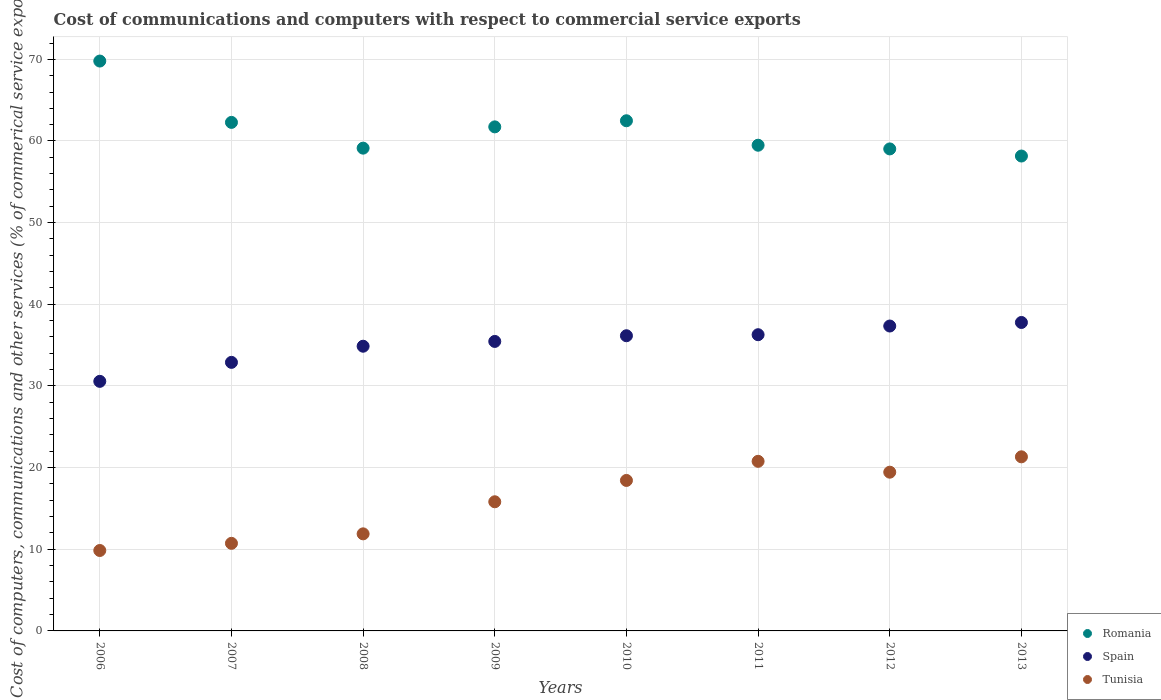Is the number of dotlines equal to the number of legend labels?
Provide a succinct answer. Yes. What is the cost of communications and computers in Romania in 2012?
Your response must be concise. 59.03. Across all years, what is the maximum cost of communications and computers in Romania?
Your response must be concise. 69.79. Across all years, what is the minimum cost of communications and computers in Tunisia?
Your response must be concise. 9.85. In which year was the cost of communications and computers in Spain maximum?
Offer a very short reply. 2013. What is the total cost of communications and computers in Romania in the graph?
Your answer should be very brief. 492.07. What is the difference between the cost of communications and computers in Spain in 2009 and that in 2011?
Provide a succinct answer. -0.82. What is the difference between the cost of communications and computers in Tunisia in 2009 and the cost of communications and computers in Romania in 2007?
Provide a succinct answer. -46.46. What is the average cost of communications and computers in Romania per year?
Make the answer very short. 61.51. In the year 2010, what is the difference between the cost of communications and computers in Spain and cost of communications and computers in Tunisia?
Your response must be concise. 17.72. What is the ratio of the cost of communications and computers in Romania in 2007 to that in 2010?
Ensure brevity in your answer.  1. Is the difference between the cost of communications and computers in Spain in 2007 and 2008 greater than the difference between the cost of communications and computers in Tunisia in 2007 and 2008?
Your answer should be very brief. No. What is the difference between the highest and the second highest cost of communications and computers in Tunisia?
Ensure brevity in your answer.  0.55. What is the difference between the highest and the lowest cost of communications and computers in Spain?
Keep it short and to the point. 7.21. Is it the case that in every year, the sum of the cost of communications and computers in Romania and cost of communications and computers in Spain  is greater than the cost of communications and computers in Tunisia?
Make the answer very short. Yes. How many years are there in the graph?
Ensure brevity in your answer.  8. Are the values on the major ticks of Y-axis written in scientific E-notation?
Give a very brief answer. No. Does the graph contain any zero values?
Your response must be concise. No. Does the graph contain grids?
Offer a terse response. Yes. How are the legend labels stacked?
Make the answer very short. Vertical. What is the title of the graph?
Your answer should be compact. Cost of communications and computers with respect to commercial service exports. What is the label or title of the X-axis?
Provide a succinct answer. Years. What is the label or title of the Y-axis?
Your answer should be very brief. Cost of computers, communications and other services (% of commerical service exports). What is the Cost of computers, communications and other services (% of commerical service exports) in Romania in 2006?
Make the answer very short. 69.79. What is the Cost of computers, communications and other services (% of commerical service exports) in Spain in 2006?
Offer a very short reply. 30.56. What is the Cost of computers, communications and other services (% of commerical service exports) in Tunisia in 2006?
Give a very brief answer. 9.85. What is the Cost of computers, communications and other services (% of commerical service exports) in Romania in 2007?
Your answer should be compact. 62.28. What is the Cost of computers, communications and other services (% of commerical service exports) of Spain in 2007?
Give a very brief answer. 32.89. What is the Cost of computers, communications and other services (% of commerical service exports) in Tunisia in 2007?
Your answer should be very brief. 10.73. What is the Cost of computers, communications and other services (% of commerical service exports) of Romania in 2008?
Keep it short and to the point. 59.12. What is the Cost of computers, communications and other services (% of commerical service exports) of Spain in 2008?
Provide a short and direct response. 34.87. What is the Cost of computers, communications and other services (% of commerical service exports) of Tunisia in 2008?
Keep it short and to the point. 11.89. What is the Cost of computers, communications and other services (% of commerical service exports) in Romania in 2009?
Your response must be concise. 61.73. What is the Cost of computers, communications and other services (% of commerical service exports) of Spain in 2009?
Make the answer very short. 35.45. What is the Cost of computers, communications and other services (% of commerical service exports) in Tunisia in 2009?
Make the answer very short. 15.82. What is the Cost of computers, communications and other services (% of commerical service exports) of Romania in 2010?
Give a very brief answer. 62.48. What is the Cost of computers, communications and other services (% of commerical service exports) in Spain in 2010?
Offer a terse response. 36.15. What is the Cost of computers, communications and other services (% of commerical service exports) of Tunisia in 2010?
Ensure brevity in your answer.  18.43. What is the Cost of computers, communications and other services (% of commerical service exports) in Romania in 2011?
Provide a succinct answer. 59.48. What is the Cost of computers, communications and other services (% of commerical service exports) in Spain in 2011?
Ensure brevity in your answer.  36.28. What is the Cost of computers, communications and other services (% of commerical service exports) in Tunisia in 2011?
Give a very brief answer. 20.77. What is the Cost of computers, communications and other services (% of commerical service exports) in Romania in 2012?
Keep it short and to the point. 59.03. What is the Cost of computers, communications and other services (% of commerical service exports) of Spain in 2012?
Offer a very short reply. 37.34. What is the Cost of computers, communications and other services (% of commerical service exports) in Tunisia in 2012?
Offer a very short reply. 19.44. What is the Cost of computers, communications and other services (% of commerical service exports) of Romania in 2013?
Your answer should be very brief. 58.16. What is the Cost of computers, communications and other services (% of commerical service exports) in Spain in 2013?
Ensure brevity in your answer.  37.77. What is the Cost of computers, communications and other services (% of commerical service exports) in Tunisia in 2013?
Give a very brief answer. 21.32. Across all years, what is the maximum Cost of computers, communications and other services (% of commerical service exports) of Romania?
Your answer should be very brief. 69.79. Across all years, what is the maximum Cost of computers, communications and other services (% of commerical service exports) in Spain?
Keep it short and to the point. 37.77. Across all years, what is the maximum Cost of computers, communications and other services (% of commerical service exports) in Tunisia?
Keep it short and to the point. 21.32. Across all years, what is the minimum Cost of computers, communications and other services (% of commerical service exports) of Romania?
Keep it short and to the point. 58.16. Across all years, what is the minimum Cost of computers, communications and other services (% of commerical service exports) in Spain?
Your answer should be very brief. 30.56. Across all years, what is the minimum Cost of computers, communications and other services (% of commerical service exports) of Tunisia?
Your response must be concise. 9.85. What is the total Cost of computers, communications and other services (% of commerical service exports) of Romania in the graph?
Your answer should be very brief. 492.07. What is the total Cost of computers, communications and other services (% of commerical service exports) of Spain in the graph?
Your response must be concise. 281.31. What is the total Cost of computers, communications and other services (% of commerical service exports) of Tunisia in the graph?
Keep it short and to the point. 128.24. What is the difference between the Cost of computers, communications and other services (% of commerical service exports) in Romania in 2006 and that in 2007?
Provide a short and direct response. 7.51. What is the difference between the Cost of computers, communications and other services (% of commerical service exports) in Spain in 2006 and that in 2007?
Your answer should be very brief. -2.33. What is the difference between the Cost of computers, communications and other services (% of commerical service exports) in Tunisia in 2006 and that in 2007?
Provide a short and direct response. -0.88. What is the difference between the Cost of computers, communications and other services (% of commerical service exports) of Romania in 2006 and that in 2008?
Keep it short and to the point. 10.67. What is the difference between the Cost of computers, communications and other services (% of commerical service exports) in Spain in 2006 and that in 2008?
Your answer should be compact. -4.3. What is the difference between the Cost of computers, communications and other services (% of commerical service exports) of Tunisia in 2006 and that in 2008?
Your answer should be very brief. -2.04. What is the difference between the Cost of computers, communications and other services (% of commerical service exports) of Romania in 2006 and that in 2009?
Your answer should be compact. 8.06. What is the difference between the Cost of computers, communications and other services (% of commerical service exports) in Spain in 2006 and that in 2009?
Offer a very short reply. -4.89. What is the difference between the Cost of computers, communications and other services (% of commerical service exports) of Tunisia in 2006 and that in 2009?
Keep it short and to the point. -5.97. What is the difference between the Cost of computers, communications and other services (% of commerical service exports) of Romania in 2006 and that in 2010?
Provide a short and direct response. 7.31. What is the difference between the Cost of computers, communications and other services (% of commerical service exports) of Spain in 2006 and that in 2010?
Provide a succinct answer. -5.59. What is the difference between the Cost of computers, communications and other services (% of commerical service exports) of Tunisia in 2006 and that in 2010?
Offer a very short reply. -8.58. What is the difference between the Cost of computers, communications and other services (% of commerical service exports) of Romania in 2006 and that in 2011?
Your answer should be compact. 10.31. What is the difference between the Cost of computers, communications and other services (% of commerical service exports) of Spain in 2006 and that in 2011?
Your response must be concise. -5.71. What is the difference between the Cost of computers, communications and other services (% of commerical service exports) in Tunisia in 2006 and that in 2011?
Provide a short and direct response. -10.92. What is the difference between the Cost of computers, communications and other services (% of commerical service exports) of Romania in 2006 and that in 2012?
Your answer should be compact. 10.76. What is the difference between the Cost of computers, communications and other services (% of commerical service exports) in Spain in 2006 and that in 2012?
Provide a succinct answer. -6.78. What is the difference between the Cost of computers, communications and other services (% of commerical service exports) in Tunisia in 2006 and that in 2012?
Your answer should be very brief. -9.59. What is the difference between the Cost of computers, communications and other services (% of commerical service exports) of Romania in 2006 and that in 2013?
Offer a terse response. 11.63. What is the difference between the Cost of computers, communications and other services (% of commerical service exports) in Spain in 2006 and that in 2013?
Offer a very short reply. -7.21. What is the difference between the Cost of computers, communications and other services (% of commerical service exports) of Tunisia in 2006 and that in 2013?
Your response must be concise. -11.47. What is the difference between the Cost of computers, communications and other services (% of commerical service exports) of Romania in 2007 and that in 2008?
Offer a very short reply. 3.15. What is the difference between the Cost of computers, communications and other services (% of commerical service exports) in Spain in 2007 and that in 2008?
Offer a terse response. -1.98. What is the difference between the Cost of computers, communications and other services (% of commerical service exports) in Tunisia in 2007 and that in 2008?
Provide a short and direct response. -1.16. What is the difference between the Cost of computers, communications and other services (% of commerical service exports) in Romania in 2007 and that in 2009?
Your response must be concise. 0.55. What is the difference between the Cost of computers, communications and other services (% of commerical service exports) in Spain in 2007 and that in 2009?
Provide a short and direct response. -2.56. What is the difference between the Cost of computers, communications and other services (% of commerical service exports) in Tunisia in 2007 and that in 2009?
Your answer should be compact. -5.09. What is the difference between the Cost of computers, communications and other services (% of commerical service exports) in Romania in 2007 and that in 2010?
Make the answer very short. -0.2. What is the difference between the Cost of computers, communications and other services (% of commerical service exports) of Spain in 2007 and that in 2010?
Your answer should be very brief. -3.26. What is the difference between the Cost of computers, communications and other services (% of commerical service exports) of Tunisia in 2007 and that in 2010?
Provide a short and direct response. -7.7. What is the difference between the Cost of computers, communications and other services (% of commerical service exports) in Romania in 2007 and that in 2011?
Offer a very short reply. 2.8. What is the difference between the Cost of computers, communications and other services (% of commerical service exports) of Spain in 2007 and that in 2011?
Make the answer very short. -3.39. What is the difference between the Cost of computers, communications and other services (% of commerical service exports) in Tunisia in 2007 and that in 2011?
Give a very brief answer. -10.04. What is the difference between the Cost of computers, communications and other services (% of commerical service exports) of Romania in 2007 and that in 2012?
Make the answer very short. 3.25. What is the difference between the Cost of computers, communications and other services (% of commerical service exports) of Spain in 2007 and that in 2012?
Provide a short and direct response. -4.45. What is the difference between the Cost of computers, communications and other services (% of commerical service exports) in Tunisia in 2007 and that in 2012?
Your response must be concise. -8.71. What is the difference between the Cost of computers, communications and other services (% of commerical service exports) of Romania in 2007 and that in 2013?
Keep it short and to the point. 4.12. What is the difference between the Cost of computers, communications and other services (% of commerical service exports) of Spain in 2007 and that in 2013?
Your answer should be compact. -4.89. What is the difference between the Cost of computers, communications and other services (% of commerical service exports) in Tunisia in 2007 and that in 2013?
Offer a very short reply. -10.6. What is the difference between the Cost of computers, communications and other services (% of commerical service exports) of Romania in 2008 and that in 2009?
Provide a succinct answer. -2.61. What is the difference between the Cost of computers, communications and other services (% of commerical service exports) in Spain in 2008 and that in 2009?
Keep it short and to the point. -0.59. What is the difference between the Cost of computers, communications and other services (% of commerical service exports) of Tunisia in 2008 and that in 2009?
Give a very brief answer. -3.93. What is the difference between the Cost of computers, communications and other services (% of commerical service exports) of Romania in 2008 and that in 2010?
Give a very brief answer. -3.35. What is the difference between the Cost of computers, communications and other services (% of commerical service exports) in Spain in 2008 and that in 2010?
Provide a succinct answer. -1.28. What is the difference between the Cost of computers, communications and other services (% of commerical service exports) in Tunisia in 2008 and that in 2010?
Ensure brevity in your answer.  -6.54. What is the difference between the Cost of computers, communications and other services (% of commerical service exports) of Romania in 2008 and that in 2011?
Give a very brief answer. -0.36. What is the difference between the Cost of computers, communications and other services (% of commerical service exports) of Spain in 2008 and that in 2011?
Your response must be concise. -1.41. What is the difference between the Cost of computers, communications and other services (% of commerical service exports) of Tunisia in 2008 and that in 2011?
Offer a terse response. -8.88. What is the difference between the Cost of computers, communications and other services (% of commerical service exports) in Romania in 2008 and that in 2012?
Ensure brevity in your answer.  0.09. What is the difference between the Cost of computers, communications and other services (% of commerical service exports) in Spain in 2008 and that in 2012?
Give a very brief answer. -2.47. What is the difference between the Cost of computers, communications and other services (% of commerical service exports) of Tunisia in 2008 and that in 2012?
Provide a succinct answer. -7.55. What is the difference between the Cost of computers, communications and other services (% of commerical service exports) in Romania in 2008 and that in 2013?
Ensure brevity in your answer.  0.97. What is the difference between the Cost of computers, communications and other services (% of commerical service exports) of Spain in 2008 and that in 2013?
Offer a very short reply. -2.91. What is the difference between the Cost of computers, communications and other services (% of commerical service exports) in Tunisia in 2008 and that in 2013?
Your response must be concise. -9.43. What is the difference between the Cost of computers, communications and other services (% of commerical service exports) of Romania in 2009 and that in 2010?
Your answer should be very brief. -0.75. What is the difference between the Cost of computers, communications and other services (% of commerical service exports) of Spain in 2009 and that in 2010?
Ensure brevity in your answer.  -0.7. What is the difference between the Cost of computers, communications and other services (% of commerical service exports) of Tunisia in 2009 and that in 2010?
Provide a succinct answer. -2.61. What is the difference between the Cost of computers, communications and other services (% of commerical service exports) of Romania in 2009 and that in 2011?
Offer a very short reply. 2.25. What is the difference between the Cost of computers, communications and other services (% of commerical service exports) in Spain in 2009 and that in 2011?
Give a very brief answer. -0.82. What is the difference between the Cost of computers, communications and other services (% of commerical service exports) in Tunisia in 2009 and that in 2011?
Offer a very short reply. -4.95. What is the difference between the Cost of computers, communications and other services (% of commerical service exports) in Romania in 2009 and that in 2012?
Ensure brevity in your answer.  2.7. What is the difference between the Cost of computers, communications and other services (% of commerical service exports) of Spain in 2009 and that in 2012?
Ensure brevity in your answer.  -1.89. What is the difference between the Cost of computers, communications and other services (% of commerical service exports) in Tunisia in 2009 and that in 2012?
Provide a succinct answer. -3.62. What is the difference between the Cost of computers, communications and other services (% of commerical service exports) in Romania in 2009 and that in 2013?
Make the answer very short. 3.57. What is the difference between the Cost of computers, communications and other services (% of commerical service exports) of Spain in 2009 and that in 2013?
Offer a very short reply. -2.32. What is the difference between the Cost of computers, communications and other services (% of commerical service exports) in Tunisia in 2009 and that in 2013?
Keep it short and to the point. -5.51. What is the difference between the Cost of computers, communications and other services (% of commerical service exports) in Romania in 2010 and that in 2011?
Give a very brief answer. 3. What is the difference between the Cost of computers, communications and other services (% of commerical service exports) of Spain in 2010 and that in 2011?
Make the answer very short. -0.13. What is the difference between the Cost of computers, communications and other services (% of commerical service exports) in Tunisia in 2010 and that in 2011?
Your response must be concise. -2.34. What is the difference between the Cost of computers, communications and other services (% of commerical service exports) in Romania in 2010 and that in 2012?
Offer a terse response. 3.45. What is the difference between the Cost of computers, communications and other services (% of commerical service exports) of Spain in 2010 and that in 2012?
Offer a very short reply. -1.19. What is the difference between the Cost of computers, communications and other services (% of commerical service exports) in Tunisia in 2010 and that in 2012?
Offer a terse response. -1.01. What is the difference between the Cost of computers, communications and other services (% of commerical service exports) of Romania in 2010 and that in 2013?
Your answer should be very brief. 4.32. What is the difference between the Cost of computers, communications and other services (% of commerical service exports) of Spain in 2010 and that in 2013?
Your answer should be compact. -1.63. What is the difference between the Cost of computers, communications and other services (% of commerical service exports) in Tunisia in 2010 and that in 2013?
Offer a terse response. -2.89. What is the difference between the Cost of computers, communications and other services (% of commerical service exports) in Romania in 2011 and that in 2012?
Make the answer very short. 0.45. What is the difference between the Cost of computers, communications and other services (% of commerical service exports) in Spain in 2011 and that in 2012?
Your answer should be very brief. -1.06. What is the difference between the Cost of computers, communications and other services (% of commerical service exports) of Tunisia in 2011 and that in 2012?
Keep it short and to the point. 1.33. What is the difference between the Cost of computers, communications and other services (% of commerical service exports) in Romania in 2011 and that in 2013?
Provide a short and direct response. 1.32. What is the difference between the Cost of computers, communications and other services (% of commerical service exports) of Spain in 2011 and that in 2013?
Your answer should be compact. -1.5. What is the difference between the Cost of computers, communications and other services (% of commerical service exports) in Tunisia in 2011 and that in 2013?
Your answer should be very brief. -0.55. What is the difference between the Cost of computers, communications and other services (% of commerical service exports) in Romania in 2012 and that in 2013?
Your response must be concise. 0.87. What is the difference between the Cost of computers, communications and other services (% of commerical service exports) in Spain in 2012 and that in 2013?
Offer a very short reply. -0.43. What is the difference between the Cost of computers, communications and other services (% of commerical service exports) in Tunisia in 2012 and that in 2013?
Ensure brevity in your answer.  -1.88. What is the difference between the Cost of computers, communications and other services (% of commerical service exports) in Romania in 2006 and the Cost of computers, communications and other services (% of commerical service exports) in Spain in 2007?
Your answer should be compact. 36.9. What is the difference between the Cost of computers, communications and other services (% of commerical service exports) of Romania in 2006 and the Cost of computers, communications and other services (% of commerical service exports) of Tunisia in 2007?
Your answer should be compact. 59.06. What is the difference between the Cost of computers, communications and other services (% of commerical service exports) in Spain in 2006 and the Cost of computers, communications and other services (% of commerical service exports) in Tunisia in 2007?
Offer a terse response. 19.84. What is the difference between the Cost of computers, communications and other services (% of commerical service exports) of Romania in 2006 and the Cost of computers, communications and other services (% of commerical service exports) of Spain in 2008?
Give a very brief answer. 34.92. What is the difference between the Cost of computers, communications and other services (% of commerical service exports) in Romania in 2006 and the Cost of computers, communications and other services (% of commerical service exports) in Tunisia in 2008?
Give a very brief answer. 57.9. What is the difference between the Cost of computers, communications and other services (% of commerical service exports) of Spain in 2006 and the Cost of computers, communications and other services (% of commerical service exports) of Tunisia in 2008?
Keep it short and to the point. 18.68. What is the difference between the Cost of computers, communications and other services (% of commerical service exports) of Romania in 2006 and the Cost of computers, communications and other services (% of commerical service exports) of Spain in 2009?
Give a very brief answer. 34.34. What is the difference between the Cost of computers, communications and other services (% of commerical service exports) of Romania in 2006 and the Cost of computers, communications and other services (% of commerical service exports) of Tunisia in 2009?
Your answer should be compact. 53.97. What is the difference between the Cost of computers, communications and other services (% of commerical service exports) in Spain in 2006 and the Cost of computers, communications and other services (% of commerical service exports) in Tunisia in 2009?
Ensure brevity in your answer.  14.75. What is the difference between the Cost of computers, communications and other services (% of commerical service exports) in Romania in 2006 and the Cost of computers, communications and other services (% of commerical service exports) in Spain in 2010?
Your response must be concise. 33.64. What is the difference between the Cost of computers, communications and other services (% of commerical service exports) in Romania in 2006 and the Cost of computers, communications and other services (% of commerical service exports) in Tunisia in 2010?
Provide a succinct answer. 51.36. What is the difference between the Cost of computers, communications and other services (% of commerical service exports) in Spain in 2006 and the Cost of computers, communications and other services (% of commerical service exports) in Tunisia in 2010?
Provide a short and direct response. 12.13. What is the difference between the Cost of computers, communications and other services (% of commerical service exports) of Romania in 2006 and the Cost of computers, communications and other services (% of commerical service exports) of Spain in 2011?
Give a very brief answer. 33.51. What is the difference between the Cost of computers, communications and other services (% of commerical service exports) of Romania in 2006 and the Cost of computers, communications and other services (% of commerical service exports) of Tunisia in 2011?
Your response must be concise. 49.02. What is the difference between the Cost of computers, communications and other services (% of commerical service exports) of Spain in 2006 and the Cost of computers, communications and other services (% of commerical service exports) of Tunisia in 2011?
Provide a succinct answer. 9.79. What is the difference between the Cost of computers, communications and other services (% of commerical service exports) of Romania in 2006 and the Cost of computers, communications and other services (% of commerical service exports) of Spain in 2012?
Offer a very short reply. 32.45. What is the difference between the Cost of computers, communications and other services (% of commerical service exports) of Romania in 2006 and the Cost of computers, communications and other services (% of commerical service exports) of Tunisia in 2012?
Make the answer very short. 50.35. What is the difference between the Cost of computers, communications and other services (% of commerical service exports) in Spain in 2006 and the Cost of computers, communications and other services (% of commerical service exports) in Tunisia in 2012?
Provide a succinct answer. 11.12. What is the difference between the Cost of computers, communications and other services (% of commerical service exports) of Romania in 2006 and the Cost of computers, communications and other services (% of commerical service exports) of Spain in 2013?
Your response must be concise. 32.02. What is the difference between the Cost of computers, communications and other services (% of commerical service exports) of Romania in 2006 and the Cost of computers, communications and other services (% of commerical service exports) of Tunisia in 2013?
Provide a short and direct response. 48.47. What is the difference between the Cost of computers, communications and other services (% of commerical service exports) of Spain in 2006 and the Cost of computers, communications and other services (% of commerical service exports) of Tunisia in 2013?
Ensure brevity in your answer.  9.24. What is the difference between the Cost of computers, communications and other services (% of commerical service exports) of Romania in 2007 and the Cost of computers, communications and other services (% of commerical service exports) of Spain in 2008?
Your answer should be very brief. 27.41. What is the difference between the Cost of computers, communications and other services (% of commerical service exports) of Romania in 2007 and the Cost of computers, communications and other services (% of commerical service exports) of Tunisia in 2008?
Provide a short and direct response. 50.39. What is the difference between the Cost of computers, communications and other services (% of commerical service exports) of Spain in 2007 and the Cost of computers, communications and other services (% of commerical service exports) of Tunisia in 2008?
Offer a terse response. 21. What is the difference between the Cost of computers, communications and other services (% of commerical service exports) of Romania in 2007 and the Cost of computers, communications and other services (% of commerical service exports) of Spain in 2009?
Make the answer very short. 26.83. What is the difference between the Cost of computers, communications and other services (% of commerical service exports) of Romania in 2007 and the Cost of computers, communications and other services (% of commerical service exports) of Tunisia in 2009?
Your response must be concise. 46.46. What is the difference between the Cost of computers, communications and other services (% of commerical service exports) of Spain in 2007 and the Cost of computers, communications and other services (% of commerical service exports) of Tunisia in 2009?
Your answer should be compact. 17.07. What is the difference between the Cost of computers, communications and other services (% of commerical service exports) in Romania in 2007 and the Cost of computers, communications and other services (% of commerical service exports) in Spain in 2010?
Offer a very short reply. 26.13. What is the difference between the Cost of computers, communications and other services (% of commerical service exports) in Romania in 2007 and the Cost of computers, communications and other services (% of commerical service exports) in Tunisia in 2010?
Give a very brief answer. 43.85. What is the difference between the Cost of computers, communications and other services (% of commerical service exports) in Spain in 2007 and the Cost of computers, communications and other services (% of commerical service exports) in Tunisia in 2010?
Your response must be concise. 14.46. What is the difference between the Cost of computers, communications and other services (% of commerical service exports) in Romania in 2007 and the Cost of computers, communications and other services (% of commerical service exports) in Spain in 2011?
Your answer should be compact. 26. What is the difference between the Cost of computers, communications and other services (% of commerical service exports) in Romania in 2007 and the Cost of computers, communications and other services (% of commerical service exports) in Tunisia in 2011?
Provide a succinct answer. 41.51. What is the difference between the Cost of computers, communications and other services (% of commerical service exports) in Spain in 2007 and the Cost of computers, communications and other services (% of commerical service exports) in Tunisia in 2011?
Provide a short and direct response. 12.12. What is the difference between the Cost of computers, communications and other services (% of commerical service exports) of Romania in 2007 and the Cost of computers, communications and other services (% of commerical service exports) of Spain in 2012?
Provide a short and direct response. 24.94. What is the difference between the Cost of computers, communications and other services (% of commerical service exports) of Romania in 2007 and the Cost of computers, communications and other services (% of commerical service exports) of Tunisia in 2012?
Give a very brief answer. 42.84. What is the difference between the Cost of computers, communications and other services (% of commerical service exports) of Spain in 2007 and the Cost of computers, communications and other services (% of commerical service exports) of Tunisia in 2012?
Your response must be concise. 13.45. What is the difference between the Cost of computers, communications and other services (% of commerical service exports) in Romania in 2007 and the Cost of computers, communications and other services (% of commerical service exports) in Spain in 2013?
Offer a terse response. 24.5. What is the difference between the Cost of computers, communications and other services (% of commerical service exports) in Romania in 2007 and the Cost of computers, communications and other services (% of commerical service exports) in Tunisia in 2013?
Provide a succinct answer. 40.96. What is the difference between the Cost of computers, communications and other services (% of commerical service exports) in Spain in 2007 and the Cost of computers, communications and other services (% of commerical service exports) in Tunisia in 2013?
Give a very brief answer. 11.57. What is the difference between the Cost of computers, communications and other services (% of commerical service exports) in Romania in 2008 and the Cost of computers, communications and other services (% of commerical service exports) in Spain in 2009?
Your answer should be compact. 23.67. What is the difference between the Cost of computers, communications and other services (% of commerical service exports) in Romania in 2008 and the Cost of computers, communications and other services (% of commerical service exports) in Tunisia in 2009?
Give a very brief answer. 43.31. What is the difference between the Cost of computers, communications and other services (% of commerical service exports) of Spain in 2008 and the Cost of computers, communications and other services (% of commerical service exports) of Tunisia in 2009?
Offer a terse response. 19.05. What is the difference between the Cost of computers, communications and other services (% of commerical service exports) of Romania in 2008 and the Cost of computers, communications and other services (% of commerical service exports) of Spain in 2010?
Provide a succinct answer. 22.97. What is the difference between the Cost of computers, communications and other services (% of commerical service exports) in Romania in 2008 and the Cost of computers, communications and other services (% of commerical service exports) in Tunisia in 2010?
Your answer should be compact. 40.7. What is the difference between the Cost of computers, communications and other services (% of commerical service exports) of Spain in 2008 and the Cost of computers, communications and other services (% of commerical service exports) of Tunisia in 2010?
Offer a terse response. 16.44. What is the difference between the Cost of computers, communications and other services (% of commerical service exports) in Romania in 2008 and the Cost of computers, communications and other services (% of commerical service exports) in Spain in 2011?
Your answer should be compact. 22.85. What is the difference between the Cost of computers, communications and other services (% of commerical service exports) in Romania in 2008 and the Cost of computers, communications and other services (% of commerical service exports) in Tunisia in 2011?
Make the answer very short. 38.35. What is the difference between the Cost of computers, communications and other services (% of commerical service exports) of Spain in 2008 and the Cost of computers, communications and other services (% of commerical service exports) of Tunisia in 2011?
Your response must be concise. 14.1. What is the difference between the Cost of computers, communications and other services (% of commerical service exports) in Romania in 2008 and the Cost of computers, communications and other services (% of commerical service exports) in Spain in 2012?
Provide a short and direct response. 21.78. What is the difference between the Cost of computers, communications and other services (% of commerical service exports) of Romania in 2008 and the Cost of computers, communications and other services (% of commerical service exports) of Tunisia in 2012?
Your answer should be very brief. 39.68. What is the difference between the Cost of computers, communications and other services (% of commerical service exports) in Spain in 2008 and the Cost of computers, communications and other services (% of commerical service exports) in Tunisia in 2012?
Your response must be concise. 15.43. What is the difference between the Cost of computers, communications and other services (% of commerical service exports) of Romania in 2008 and the Cost of computers, communications and other services (% of commerical service exports) of Spain in 2013?
Your answer should be compact. 21.35. What is the difference between the Cost of computers, communications and other services (% of commerical service exports) in Romania in 2008 and the Cost of computers, communications and other services (% of commerical service exports) in Tunisia in 2013?
Give a very brief answer. 37.8. What is the difference between the Cost of computers, communications and other services (% of commerical service exports) of Spain in 2008 and the Cost of computers, communications and other services (% of commerical service exports) of Tunisia in 2013?
Offer a very short reply. 13.54. What is the difference between the Cost of computers, communications and other services (% of commerical service exports) of Romania in 2009 and the Cost of computers, communications and other services (% of commerical service exports) of Spain in 2010?
Keep it short and to the point. 25.58. What is the difference between the Cost of computers, communications and other services (% of commerical service exports) in Romania in 2009 and the Cost of computers, communications and other services (% of commerical service exports) in Tunisia in 2010?
Keep it short and to the point. 43.3. What is the difference between the Cost of computers, communications and other services (% of commerical service exports) of Spain in 2009 and the Cost of computers, communications and other services (% of commerical service exports) of Tunisia in 2010?
Provide a short and direct response. 17.02. What is the difference between the Cost of computers, communications and other services (% of commerical service exports) in Romania in 2009 and the Cost of computers, communications and other services (% of commerical service exports) in Spain in 2011?
Ensure brevity in your answer.  25.45. What is the difference between the Cost of computers, communications and other services (% of commerical service exports) in Romania in 2009 and the Cost of computers, communications and other services (% of commerical service exports) in Tunisia in 2011?
Provide a short and direct response. 40.96. What is the difference between the Cost of computers, communications and other services (% of commerical service exports) in Spain in 2009 and the Cost of computers, communications and other services (% of commerical service exports) in Tunisia in 2011?
Your response must be concise. 14.68. What is the difference between the Cost of computers, communications and other services (% of commerical service exports) of Romania in 2009 and the Cost of computers, communications and other services (% of commerical service exports) of Spain in 2012?
Ensure brevity in your answer.  24.39. What is the difference between the Cost of computers, communications and other services (% of commerical service exports) in Romania in 2009 and the Cost of computers, communications and other services (% of commerical service exports) in Tunisia in 2012?
Your answer should be very brief. 42.29. What is the difference between the Cost of computers, communications and other services (% of commerical service exports) in Spain in 2009 and the Cost of computers, communications and other services (% of commerical service exports) in Tunisia in 2012?
Give a very brief answer. 16.01. What is the difference between the Cost of computers, communications and other services (% of commerical service exports) in Romania in 2009 and the Cost of computers, communications and other services (% of commerical service exports) in Spain in 2013?
Your response must be concise. 23.95. What is the difference between the Cost of computers, communications and other services (% of commerical service exports) of Romania in 2009 and the Cost of computers, communications and other services (% of commerical service exports) of Tunisia in 2013?
Provide a short and direct response. 40.41. What is the difference between the Cost of computers, communications and other services (% of commerical service exports) in Spain in 2009 and the Cost of computers, communications and other services (% of commerical service exports) in Tunisia in 2013?
Make the answer very short. 14.13. What is the difference between the Cost of computers, communications and other services (% of commerical service exports) of Romania in 2010 and the Cost of computers, communications and other services (% of commerical service exports) of Spain in 2011?
Provide a short and direct response. 26.2. What is the difference between the Cost of computers, communications and other services (% of commerical service exports) of Romania in 2010 and the Cost of computers, communications and other services (% of commerical service exports) of Tunisia in 2011?
Your answer should be very brief. 41.71. What is the difference between the Cost of computers, communications and other services (% of commerical service exports) of Spain in 2010 and the Cost of computers, communications and other services (% of commerical service exports) of Tunisia in 2011?
Ensure brevity in your answer.  15.38. What is the difference between the Cost of computers, communications and other services (% of commerical service exports) in Romania in 2010 and the Cost of computers, communications and other services (% of commerical service exports) in Spain in 2012?
Keep it short and to the point. 25.14. What is the difference between the Cost of computers, communications and other services (% of commerical service exports) of Romania in 2010 and the Cost of computers, communications and other services (% of commerical service exports) of Tunisia in 2012?
Make the answer very short. 43.04. What is the difference between the Cost of computers, communications and other services (% of commerical service exports) of Spain in 2010 and the Cost of computers, communications and other services (% of commerical service exports) of Tunisia in 2012?
Give a very brief answer. 16.71. What is the difference between the Cost of computers, communications and other services (% of commerical service exports) of Romania in 2010 and the Cost of computers, communications and other services (% of commerical service exports) of Spain in 2013?
Provide a succinct answer. 24.7. What is the difference between the Cost of computers, communications and other services (% of commerical service exports) in Romania in 2010 and the Cost of computers, communications and other services (% of commerical service exports) in Tunisia in 2013?
Provide a short and direct response. 41.16. What is the difference between the Cost of computers, communications and other services (% of commerical service exports) of Spain in 2010 and the Cost of computers, communications and other services (% of commerical service exports) of Tunisia in 2013?
Provide a short and direct response. 14.83. What is the difference between the Cost of computers, communications and other services (% of commerical service exports) in Romania in 2011 and the Cost of computers, communications and other services (% of commerical service exports) in Spain in 2012?
Your answer should be compact. 22.14. What is the difference between the Cost of computers, communications and other services (% of commerical service exports) of Romania in 2011 and the Cost of computers, communications and other services (% of commerical service exports) of Tunisia in 2012?
Keep it short and to the point. 40.04. What is the difference between the Cost of computers, communications and other services (% of commerical service exports) of Spain in 2011 and the Cost of computers, communications and other services (% of commerical service exports) of Tunisia in 2012?
Give a very brief answer. 16.84. What is the difference between the Cost of computers, communications and other services (% of commerical service exports) of Romania in 2011 and the Cost of computers, communications and other services (% of commerical service exports) of Spain in 2013?
Your answer should be very brief. 21.71. What is the difference between the Cost of computers, communications and other services (% of commerical service exports) of Romania in 2011 and the Cost of computers, communications and other services (% of commerical service exports) of Tunisia in 2013?
Offer a very short reply. 38.16. What is the difference between the Cost of computers, communications and other services (% of commerical service exports) of Spain in 2011 and the Cost of computers, communications and other services (% of commerical service exports) of Tunisia in 2013?
Make the answer very short. 14.95. What is the difference between the Cost of computers, communications and other services (% of commerical service exports) of Romania in 2012 and the Cost of computers, communications and other services (% of commerical service exports) of Spain in 2013?
Provide a succinct answer. 21.25. What is the difference between the Cost of computers, communications and other services (% of commerical service exports) of Romania in 2012 and the Cost of computers, communications and other services (% of commerical service exports) of Tunisia in 2013?
Your answer should be very brief. 37.71. What is the difference between the Cost of computers, communications and other services (% of commerical service exports) in Spain in 2012 and the Cost of computers, communications and other services (% of commerical service exports) in Tunisia in 2013?
Make the answer very short. 16.02. What is the average Cost of computers, communications and other services (% of commerical service exports) of Romania per year?
Provide a succinct answer. 61.51. What is the average Cost of computers, communications and other services (% of commerical service exports) in Spain per year?
Provide a short and direct response. 35.16. What is the average Cost of computers, communications and other services (% of commerical service exports) in Tunisia per year?
Ensure brevity in your answer.  16.03. In the year 2006, what is the difference between the Cost of computers, communications and other services (% of commerical service exports) of Romania and Cost of computers, communications and other services (% of commerical service exports) of Spain?
Your response must be concise. 39.23. In the year 2006, what is the difference between the Cost of computers, communications and other services (% of commerical service exports) in Romania and Cost of computers, communications and other services (% of commerical service exports) in Tunisia?
Your response must be concise. 59.94. In the year 2006, what is the difference between the Cost of computers, communications and other services (% of commerical service exports) of Spain and Cost of computers, communications and other services (% of commerical service exports) of Tunisia?
Ensure brevity in your answer.  20.71. In the year 2007, what is the difference between the Cost of computers, communications and other services (% of commerical service exports) of Romania and Cost of computers, communications and other services (% of commerical service exports) of Spain?
Make the answer very short. 29.39. In the year 2007, what is the difference between the Cost of computers, communications and other services (% of commerical service exports) in Romania and Cost of computers, communications and other services (% of commerical service exports) in Tunisia?
Give a very brief answer. 51.55. In the year 2007, what is the difference between the Cost of computers, communications and other services (% of commerical service exports) of Spain and Cost of computers, communications and other services (% of commerical service exports) of Tunisia?
Your response must be concise. 22.16. In the year 2008, what is the difference between the Cost of computers, communications and other services (% of commerical service exports) in Romania and Cost of computers, communications and other services (% of commerical service exports) in Spain?
Your answer should be compact. 24.26. In the year 2008, what is the difference between the Cost of computers, communications and other services (% of commerical service exports) of Romania and Cost of computers, communications and other services (% of commerical service exports) of Tunisia?
Offer a terse response. 47.24. In the year 2008, what is the difference between the Cost of computers, communications and other services (% of commerical service exports) in Spain and Cost of computers, communications and other services (% of commerical service exports) in Tunisia?
Provide a short and direct response. 22.98. In the year 2009, what is the difference between the Cost of computers, communications and other services (% of commerical service exports) of Romania and Cost of computers, communications and other services (% of commerical service exports) of Spain?
Make the answer very short. 26.28. In the year 2009, what is the difference between the Cost of computers, communications and other services (% of commerical service exports) of Romania and Cost of computers, communications and other services (% of commerical service exports) of Tunisia?
Offer a very short reply. 45.91. In the year 2009, what is the difference between the Cost of computers, communications and other services (% of commerical service exports) of Spain and Cost of computers, communications and other services (% of commerical service exports) of Tunisia?
Provide a succinct answer. 19.64. In the year 2010, what is the difference between the Cost of computers, communications and other services (% of commerical service exports) of Romania and Cost of computers, communications and other services (% of commerical service exports) of Spain?
Provide a short and direct response. 26.33. In the year 2010, what is the difference between the Cost of computers, communications and other services (% of commerical service exports) of Romania and Cost of computers, communications and other services (% of commerical service exports) of Tunisia?
Your response must be concise. 44.05. In the year 2010, what is the difference between the Cost of computers, communications and other services (% of commerical service exports) in Spain and Cost of computers, communications and other services (% of commerical service exports) in Tunisia?
Make the answer very short. 17.72. In the year 2011, what is the difference between the Cost of computers, communications and other services (% of commerical service exports) in Romania and Cost of computers, communications and other services (% of commerical service exports) in Spain?
Offer a terse response. 23.2. In the year 2011, what is the difference between the Cost of computers, communications and other services (% of commerical service exports) in Romania and Cost of computers, communications and other services (% of commerical service exports) in Tunisia?
Your answer should be very brief. 38.71. In the year 2011, what is the difference between the Cost of computers, communications and other services (% of commerical service exports) in Spain and Cost of computers, communications and other services (% of commerical service exports) in Tunisia?
Your response must be concise. 15.51. In the year 2012, what is the difference between the Cost of computers, communications and other services (% of commerical service exports) of Romania and Cost of computers, communications and other services (% of commerical service exports) of Spain?
Offer a terse response. 21.69. In the year 2012, what is the difference between the Cost of computers, communications and other services (% of commerical service exports) of Romania and Cost of computers, communications and other services (% of commerical service exports) of Tunisia?
Offer a terse response. 39.59. In the year 2013, what is the difference between the Cost of computers, communications and other services (% of commerical service exports) of Romania and Cost of computers, communications and other services (% of commerical service exports) of Spain?
Ensure brevity in your answer.  20.38. In the year 2013, what is the difference between the Cost of computers, communications and other services (% of commerical service exports) in Romania and Cost of computers, communications and other services (% of commerical service exports) in Tunisia?
Offer a very short reply. 36.84. In the year 2013, what is the difference between the Cost of computers, communications and other services (% of commerical service exports) of Spain and Cost of computers, communications and other services (% of commerical service exports) of Tunisia?
Offer a terse response. 16.45. What is the ratio of the Cost of computers, communications and other services (% of commerical service exports) in Romania in 2006 to that in 2007?
Provide a succinct answer. 1.12. What is the ratio of the Cost of computers, communications and other services (% of commerical service exports) in Spain in 2006 to that in 2007?
Make the answer very short. 0.93. What is the ratio of the Cost of computers, communications and other services (% of commerical service exports) of Tunisia in 2006 to that in 2007?
Your response must be concise. 0.92. What is the ratio of the Cost of computers, communications and other services (% of commerical service exports) of Romania in 2006 to that in 2008?
Your answer should be compact. 1.18. What is the ratio of the Cost of computers, communications and other services (% of commerical service exports) in Spain in 2006 to that in 2008?
Ensure brevity in your answer.  0.88. What is the ratio of the Cost of computers, communications and other services (% of commerical service exports) in Tunisia in 2006 to that in 2008?
Provide a succinct answer. 0.83. What is the ratio of the Cost of computers, communications and other services (% of commerical service exports) in Romania in 2006 to that in 2009?
Give a very brief answer. 1.13. What is the ratio of the Cost of computers, communications and other services (% of commerical service exports) of Spain in 2006 to that in 2009?
Give a very brief answer. 0.86. What is the ratio of the Cost of computers, communications and other services (% of commerical service exports) of Tunisia in 2006 to that in 2009?
Make the answer very short. 0.62. What is the ratio of the Cost of computers, communications and other services (% of commerical service exports) in Romania in 2006 to that in 2010?
Ensure brevity in your answer.  1.12. What is the ratio of the Cost of computers, communications and other services (% of commerical service exports) of Spain in 2006 to that in 2010?
Give a very brief answer. 0.85. What is the ratio of the Cost of computers, communications and other services (% of commerical service exports) in Tunisia in 2006 to that in 2010?
Make the answer very short. 0.53. What is the ratio of the Cost of computers, communications and other services (% of commerical service exports) of Romania in 2006 to that in 2011?
Give a very brief answer. 1.17. What is the ratio of the Cost of computers, communications and other services (% of commerical service exports) of Spain in 2006 to that in 2011?
Your answer should be very brief. 0.84. What is the ratio of the Cost of computers, communications and other services (% of commerical service exports) of Tunisia in 2006 to that in 2011?
Your answer should be compact. 0.47. What is the ratio of the Cost of computers, communications and other services (% of commerical service exports) in Romania in 2006 to that in 2012?
Your answer should be very brief. 1.18. What is the ratio of the Cost of computers, communications and other services (% of commerical service exports) in Spain in 2006 to that in 2012?
Your answer should be compact. 0.82. What is the ratio of the Cost of computers, communications and other services (% of commerical service exports) in Tunisia in 2006 to that in 2012?
Provide a succinct answer. 0.51. What is the ratio of the Cost of computers, communications and other services (% of commerical service exports) of Romania in 2006 to that in 2013?
Ensure brevity in your answer.  1.2. What is the ratio of the Cost of computers, communications and other services (% of commerical service exports) in Spain in 2006 to that in 2013?
Offer a very short reply. 0.81. What is the ratio of the Cost of computers, communications and other services (% of commerical service exports) of Tunisia in 2006 to that in 2013?
Give a very brief answer. 0.46. What is the ratio of the Cost of computers, communications and other services (% of commerical service exports) in Romania in 2007 to that in 2008?
Offer a very short reply. 1.05. What is the ratio of the Cost of computers, communications and other services (% of commerical service exports) in Spain in 2007 to that in 2008?
Make the answer very short. 0.94. What is the ratio of the Cost of computers, communications and other services (% of commerical service exports) of Tunisia in 2007 to that in 2008?
Provide a succinct answer. 0.9. What is the ratio of the Cost of computers, communications and other services (% of commerical service exports) of Romania in 2007 to that in 2009?
Offer a terse response. 1.01. What is the ratio of the Cost of computers, communications and other services (% of commerical service exports) in Spain in 2007 to that in 2009?
Make the answer very short. 0.93. What is the ratio of the Cost of computers, communications and other services (% of commerical service exports) of Tunisia in 2007 to that in 2009?
Make the answer very short. 0.68. What is the ratio of the Cost of computers, communications and other services (% of commerical service exports) in Romania in 2007 to that in 2010?
Offer a terse response. 1. What is the ratio of the Cost of computers, communications and other services (% of commerical service exports) in Spain in 2007 to that in 2010?
Make the answer very short. 0.91. What is the ratio of the Cost of computers, communications and other services (% of commerical service exports) of Tunisia in 2007 to that in 2010?
Give a very brief answer. 0.58. What is the ratio of the Cost of computers, communications and other services (% of commerical service exports) in Romania in 2007 to that in 2011?
Give a very brief answer. 1.05. What is the ratio of the Cost of computers, communications and other services (% of commerical service exports) of Spain in 2007 to that in 2011?
Your response must be concise. 0.91. What is the ratio of the Cost of computers, communications and other services (% of commerical service exports) of Tunisia in 2007 to that in 2011?
Make the answer very short. 0.52. What is the ratio of the Cost of computers, communications and other services (% of commerical service exports) in Romania in 2007 to that in 2012?
Your answer should be compact. 1.05. What is the ratio of the Cost of computers, communications and other services (% of commerical service exports) of Spain in 2007 to that in 2012?
Keep it short and to the point. 0.88. What is the ratio of the Cost of computers, communications and other services (% of commerical service exports) in Tunisia in 2007 to that in 2012?
Your answer should be very brief. 0.55. What is the ratio of the Cost of computers, communications and other services (% of commerical service exports) of Romania in 2007 to that in 2013?
Ensure brevity in your answer.  1.07. What is the ratio of the Cost of computers, communications and other services (% of commerical service exports) in Spain in 2007 to that in 2013?
Ensure brevity in your answer.  0.87. What is the ratio of the Cost of computers, communications and other services (% of commerical service exports) of Tunisia in 2007 to that in 2013?
Keep it short and to the point. 0.5. What is the ratio of the Cost of computers, communications and other services (% of commerical service exports) in Romania in 2008 to that in 2009?
Provide a succinct answer. 0.96. What is the ratio of the Cost of computers, communications and other services (% of commerical service exports) of Spain in 2008 to that in 2009?
Keep it short and to the point. 0.98. What is the ratio of the Cost of computers, communications and other services (% of commerical service exports) of Tunisia in 2008 to that in 2009?
Ensure brevity in your answer.  0.75. What is the ratio of the Cost of computers, communications and other services (% of commerical service exports) of Romania in 2008 to that in 2010?
Provide a succinct answer. 0.95. What is the ratio of the Cost of computers, communications and other services (% of commerical service exports) of Spain in 2008 to that in 2010?
Provide a succinct answer. 0.96. What is the ratio of the Cost of computers, communications and other services (% of commerical service exports) in Tunisia in 2008 to that in 2010?
Your answer should be very brief. 0.65. What is the ratio of the Cost of computers, communications and other services (% of commerical service exports) of Spain in 2008 to that in 2011?
Your answer should be very brief. 0.96. What is the ratio of the Cost of computers, communications and other services (% of commerical service exports) in Tunisia in 2008 to that in 2011?
Your response must be concise. 0.57. What is the ratio of the Cost of computers, communications and other services (% of commerical service exports) of Romania in 2008 to that in 2012?
Provide a short and direct response. 1. What is the ratio of the Cost of computers, communications and other services (% of commerical service exports) of Spain in 2008 to that in 2012?
Keep it short and to the point. 0.93. What is the ratio of the Cost of computers, communications and other services (% of commerical service exports) in Tunisia in 2008 to that in 2012?
Give a very brief answer. 0.61. What is the ratio of the Cost of computers, communications and other services (% of commerical service exports) of Romania in 2008 to that in 2013?
Keep it short and to the point. 1.02. What is the ratio of the Cost of computers, communications and other services (% of commerical service exports) of Spain in 2008 to that in 2013?
Ensure brevity in your answer.  0.92. What is the ratio of the Cost of computers, communications and other services (% of commerical service exports) of Tunisia in 2008 to that in 2013?
Offer a terse response. 0.56. What is the ratio of the Cost of computers, communications and other services (% of commerical service exports) of Spain in 2009 to that in 2010?
Keep it short and to the point. 0.98. What is the ratio of the Cost of computers, communications and other services (% of commerical service exports) of Tunisia in 2009 to that in 2010?
Provide a succinct answer. 0.86. What is the ratio of the Cost of computers, communications and other services (% of commerical service exports) in Romania in 2009 to that in 2011?
Your answer should be very brief. 1.04. What is the ratio of the Cost of computers, communications and other services (% of commerical service exports) in Spain in 2009 to that in 2011?
Provide a short and direct response. 0.98. What is the ratio of the Cost of computers, communications and other services (% of commerical service exports) of Tunisia in 2009 to that in 2011?
Your answer should be compact. 0.76. What is the ratio of the Cost of computers, communications and other services (% of commerical service exports) of Romania in 2009 to that in 2012?
Offer a terse response. 1.05. What is the ratio of the Cost of computers, communications and other services (% of commerical service exports) of Spain in 2009 to that in 2012?
Your answer should be very brief. 0.95. What is the ratio of the Cost of computers, communications and other services (% of commerical service exports) in Tunisia in 2009 to that in 2012?
Provide a succinct answer. 0.81. What is the ratio of the Cost of computers, communications and other services (% of commerical service exports) of Romania in 2009 to that in 2013?
Your response must be concise. 1.06. What is the ratio of the Cost of computers, communications and other services (% of commerical service exports) in Spain in 2009 to that in 2013?
Provide a short and direct response. 0.94. What is the ratio of the Cost of computers, communications and other services (% of commerical service exports) in Tunisia in 2009 to that in 2013?
Offer a terse response. 0.74. What is the ratio of the Cost of computers, communications and other services (% of commerical service exports) in Romania in 2010 to that in 2011?
Keep it short and to the point. 1.05. What is the ratio of the Cost of computers, communications and other services (% of commerical service exports) of Tunisia in 2010 to that in 2011?
Give a very brief answer. 0.89. What is the ratio of the Cost of computers, communications and other services (% of commerical service exports) of Romania in 2010 to that in 2012?
Make the answer very short. 1.06. What is the ratio of the Cost of computers, communications and other services (% of commerical service exports) in Spain in 2010 to that in 2012?
Your answer should be compact. 0.97. What is the ratio of the Cost of computers, communications and other services (% of commerical service exports) of Tunisia in 2010 to that in 2012?
Keep it short and to the point. 0.95. What is the ratio of the Cost of computers, communications and other services (% of commerical service exports) in Romania in 2010 to that in 2013?
Provide a short and direct response. 1.07. What is the ratio of the Cost of computers, communications and other services (% of commerical service exports) of Tunisia in 2010 to that in 2013?
Give a very brief answer. 0.86. What is the ratio of the Cost of computers, communications and other services (% of commerical service exports) in Romania in 2011 to that in 2012?
Your answer should be very brief. 1.01. What is the ratio of the Cost of computers, communications and other services (% of commerical service exports) of Spain in 2011 to that in 2012?
Give a very brief answer. 0.97. What is the ratio of the Cost of computers, communications and other services (% of commerical service exports) of Tunisia in 2011 to that in 2012?
Provide a succinct answer. 1.07. What is the ratio of the Cost of computers, communications and other services (% of commerical service exports) in Romania in 2011 to that in 2013?
Offer a terse response. 1.02. What is the ratio of the Cost of computers, communications and other services (% of commerical service exports) of Spain in 2011 to that in 2013?
Your answer should be compact. 0.96. What is the ratio of the Cost of computers, communications and other services (% of commerical service exports) in Tunisia in 2011 to that in 2013?
Ensure brevity in your answer.  0.97. What is the ratio of the Cost of computers, communications and other services (% of commerical service exports) of Romania in 2012 to that in 2013?
Your response must be concise. 1.01. What is the ratio of the Cost of computers, communications and other services (% of commerical service exports) of Tunisia in 2012 to that in 2013?
Ensure brevity in your answer.  0.91. What is the difference between the highest and the second highest Cost of computers, communications and other services (% of commerical service exports) of Romania?
Ensure brevity in your answer.  7.31. What is the difference between the highest and the second highest Cost of computers, communications and other services (% of commerical service exports) of Spain?
Provide a short and direct response. 0.43. What is the difference between the highest and the second highest Cost of computers, communications and other services (% of commerical service exports) in Tunisia?
Ensure brevity in your answer.  0.55. What is the difference between the highest and the lowest Cost of computers, communications and other services (% of commerical service exports) of Romania?
Your answer should be very brief. 11.63. What is the difference between the highest and the lowest Cost of computers, communications and other services (% of commerical service exports) of Spain?
Offer a very short reply. 7.21. What is the difference between the highest and the lowest Cost of computers, communications and other services (% of commerical service exports) in Tunisia?
Ensure brevity in your answer.  11.47. 